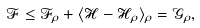<formula> <loc_0><loc_0><loc_500><loc_500>\mathcal { F } \leq \mathcal { F } _ { \rho } + \langle { \mathcal { H } } - { \mathcal { H } } _ { \rho } \rangle _ { \rho } = { \mathcal { G } } _ { \rho } ,</formula> 